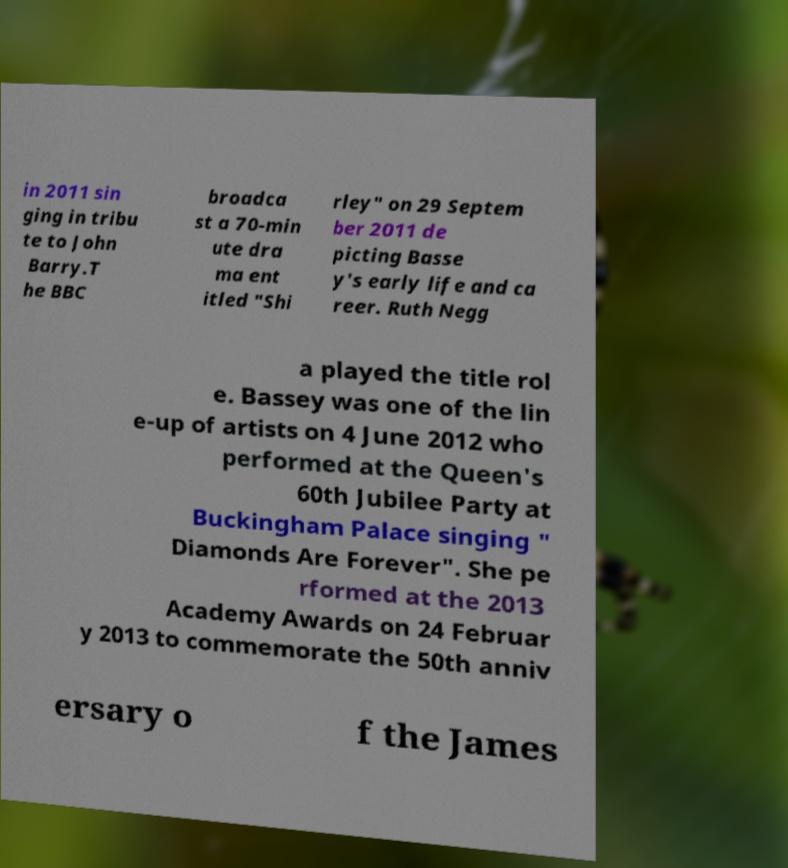Can you read and provide the text displayed in the image?This photo seems to have some interesting text. Can you extract and type it out for me? in 2011 sin ging in tribu te to John Barry.T he BBC broadca st a 70-min ute dra ma ent itled "Shi rley" on 29 Septem ber 2011 de picting Basse y's early life and ca reer. Ruth Negg a played the title rol e. Bassey was one of the lin e-up of artists on 4 June 2012 who performed at the Queen's 60th Jubilee Party at Buckingham Palace singing " Diamonds Are Forever". She pe rformed at the 2013 Academy Awards on 24 Februar y 2013 to commemorate the 50th anniv ersary o f the James 